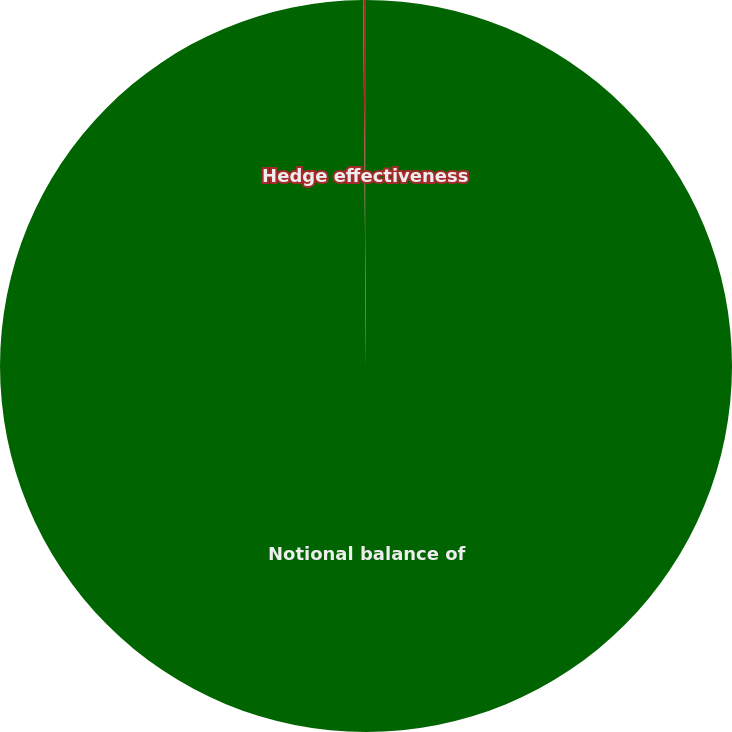Convert chart to OTSL. <chart><loc_0><loc_0><loc_500><loc_500><pie_chart><fcel>Notional balance of<fcel>Hedge effectiveness<nl><fcel>99.88%<fcel>0.12%<nl></chart> 